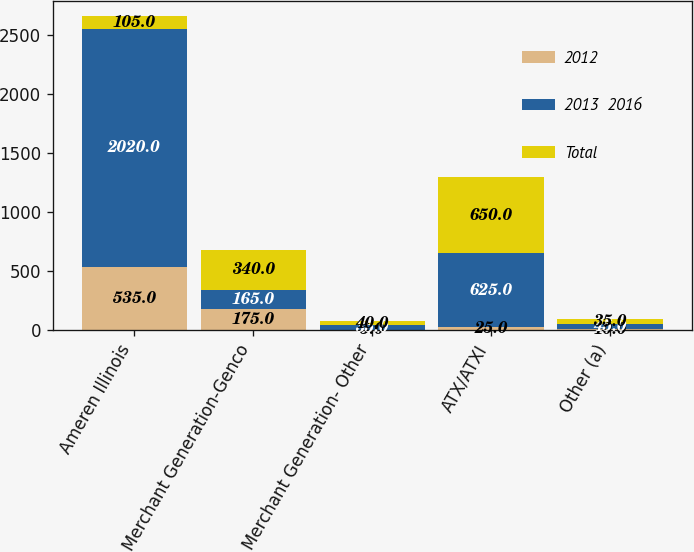<chart> <loc_0><loc_0><loc_500><loc_500><stacked_bar_chart><ecel><fcel>Ameren Illinois<fcel>Merchant Generation-Genco<fcel>Merchant Generation- Other<fcel>ATX/ATXI<fcel>Other (a)<nl><fcel>2012<fcel>535<fcel>175<fcel>5<fcel>25<fcel>10<nl><fcel>2013  2016<fcel>2020<fcel>165<fcel>35<fcel>625<fcel>45<nl><fcel>Total<fcel>105<fcel>340<fcel>40<fcel>650<fcel>35<nl></chart> 